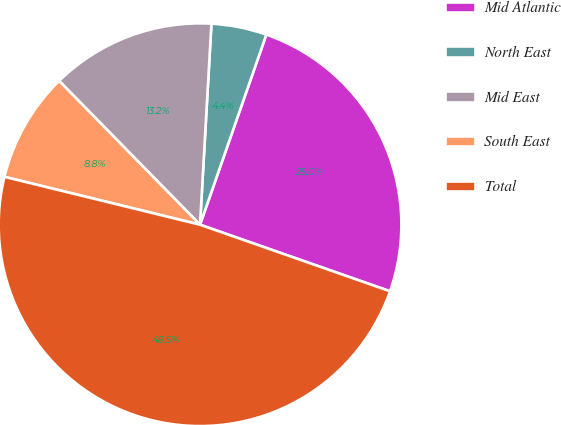<chart> <loc_0><loc_0><loc_500><loc_500><pie_chart><fcel>Mid Atlantic<fcel>North East<fcel>Mid East<fcel>South East<fcel>Total<nl><fcel>25.02%<fcel>4.44%<fcel>13.24%<fcel>8.84%<fcel>48.46%<nl></chart> 